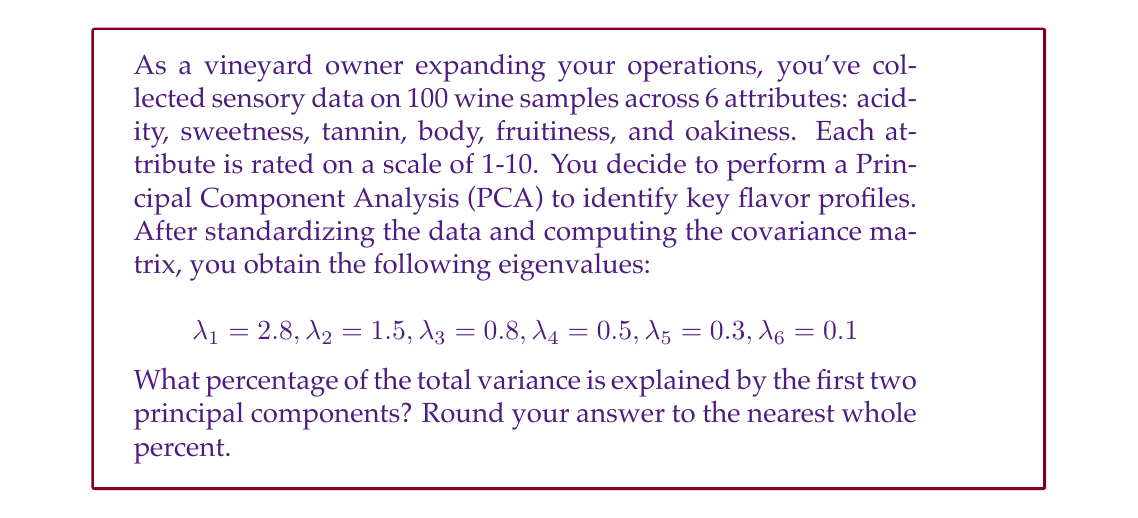Can you answer this question? To solve this problem, we'll follow these steps:

1) First, recall that in PCA, each eigenvalue represents the amount of variance explained by its corresponding principal component.

2) The total variance in the dataset is equal to the sum of all eigenvalues:

   $$\text{Total Variance} = \sum_{i=1}^6 \lambda_i = 2.8 + 1.5 + 0.8 + 0.5 + 0.3 + 0.1 = 6.0$$

3) The variance explained by the first two principal components is the sum of their corresponding eigenvalues:

   $$\text{Variance Explained} = \lambda_1 + \lambda_2 = 2.8 + 1.5 = 4.3$$

4) To calculate the percentage of variance explained, we divide the variance explained by the total variance and multiply by 100:

   $$\text{Percentage} = \frac{\text{Variance Explained}}{\text{Total Variance}} \times 100\%$$

   $$= \frac{4.3}{6.0} \times 100\% \approx 71.67\%$$

5) Rounding to the nearest whole percent gives us 72%.

This result indicates that the first two principal components capture about 72% of the total variation in your wine sensory data, which is a substantial amount and suggests that these two components represent key flavor profiles in your wines.
Answer: 72% 